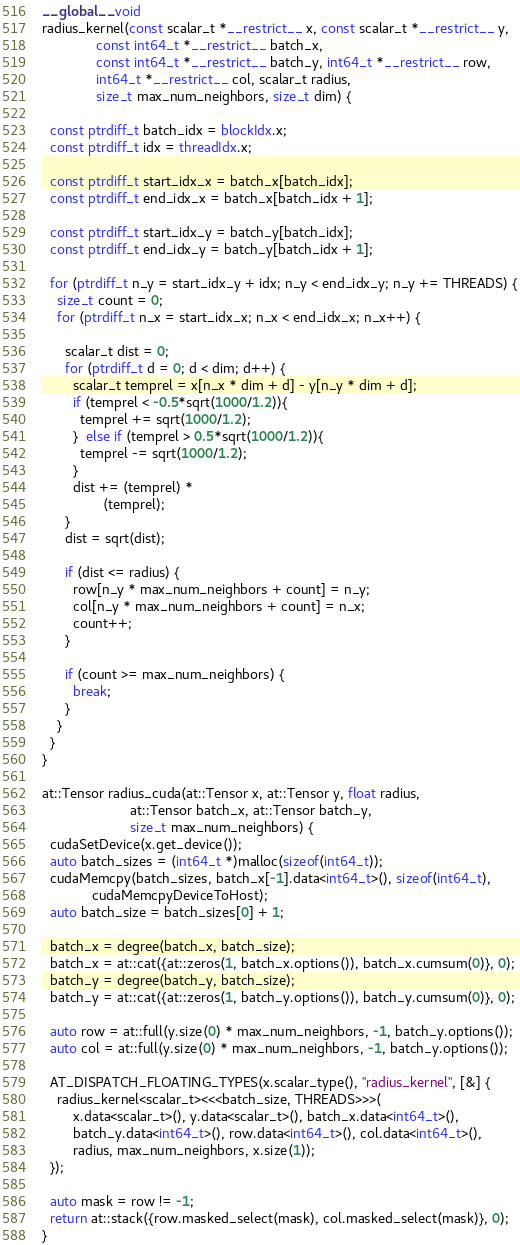Convert code to text. <code><loc_0><loc_0><loc_500><loc_500><_Cuda_>__global__ void
radius_kernel(const scalar_t *__restrict__ x, const scalar_t *__restrict__ y,
              const int64_t *__restrict__ batch_x,
              const int64_t *__restrict__ batch_y, int64_t *__restrict__ row,
              int64_t *__restrict__ col, scalar_t radius,
              size_t max_num_neighbors, size_t dim) {

  const ptrdiff_t batch_idx = blockIdx.x;
  const ptrdiff_t idx = threadIdx.x;

  const ptrdiff_t start_idx_x = batch_x[batch_idx];
  const ptrdiff_t end_idx_x = batch_x[batch_idx + 1];

  const ptrdiff_t start_idx_y = batch_y[batch_idx];
  const ptrdiff_t end_idx_y = batch_y[batch_idx + 1];

  for (ptrdiff_t n_y = start_idx_y + idx; n_y < end_idx_y; n_y += THREADS) {
    size_t count = 0;
    for (ptrdiff_t n_x = start_idx_x; n_x < end_idx_x; n_x++) {

      scalar_t dist = 0;
      for (ptrdiff_t d = 0; d < dim; d++) {
        scalar_t temprel = x[n_x * dim + d] - y[n_y * dim + d];
        if (temprel < -0.5*sqrt(1000/1.2)){
          temprel += sqrt(1000/1.2);
        }  else if (temprel > 0.5*sqrt(1000/1.2)){
          temprel -= sqrt(1000/1.2);
        }        
        dist += (temprel) *
                (temprel);
      }
      dist = sqrt(dist);

      if (dist <= radius) {
        row[n_y * max_num_neighbors + count] = n_y;
        col[n_y * max_num_neighbors + count] = n_x;
        count++;
      }

      if (count >= max_num_neighbors) {
        break;
      }
    }
  }
}

at::Tensor radius_cuda(at::Tensor x, at::Tensor y, float radius,
                       at::Tensor batch_x, at::Tensor batch_y,
                       size_t max_num_neighbors) {
  cudaSetDevice(x.get_device());
  auto batch_sizes = (int64_t *)malloc(sizeof(int64_t));
  cudaMemcpy(batch_sizes, batch_x[-1].data<int64_t>(), sizeof(int64_t),
             cudaMemcpyDeviceToHost);
  auto batch_size = batch_sizes[0] + 1;

  batch_x = degree(batch_x, batch_size);
  batch_x = at::cat({at::zeros(1, batch_x.options()), batch_x.cumsum(0)}, 0);
  batch_y = degree(batch_y, batch_size);
  batch_y = at::cat({at::zeros(1, batch_y.options()), batch_y.cumsum(0)}, 0);

  auto row = at::full(y.size(0) * max_num_neighbors, -1, batch_y.options());
  auto col = at::full(y.size(0) * max_num_neighbors, -1, batch_y.options());

  AT_DISPATCH_FLOATING_TYPES(x.scalar_type(), "radius_kernel", [&] {
    radius_kernel<scalar_t><<<batch_size, THREADS>>>(
        x.data<scalar_t>(), y.data<scalar_t>(), batch_x.data<int64_t>(),
        batch_y.data<int64_t>(), row.data<int64_t>(), col.data<int64_t>(),
        radius, max_num_neighbors, x.size(1));
  });

  auto mask = row != -1;
  return at::stack({row.masked_select(mask), col.masked_select(mask)}, 0);
}
</code> 